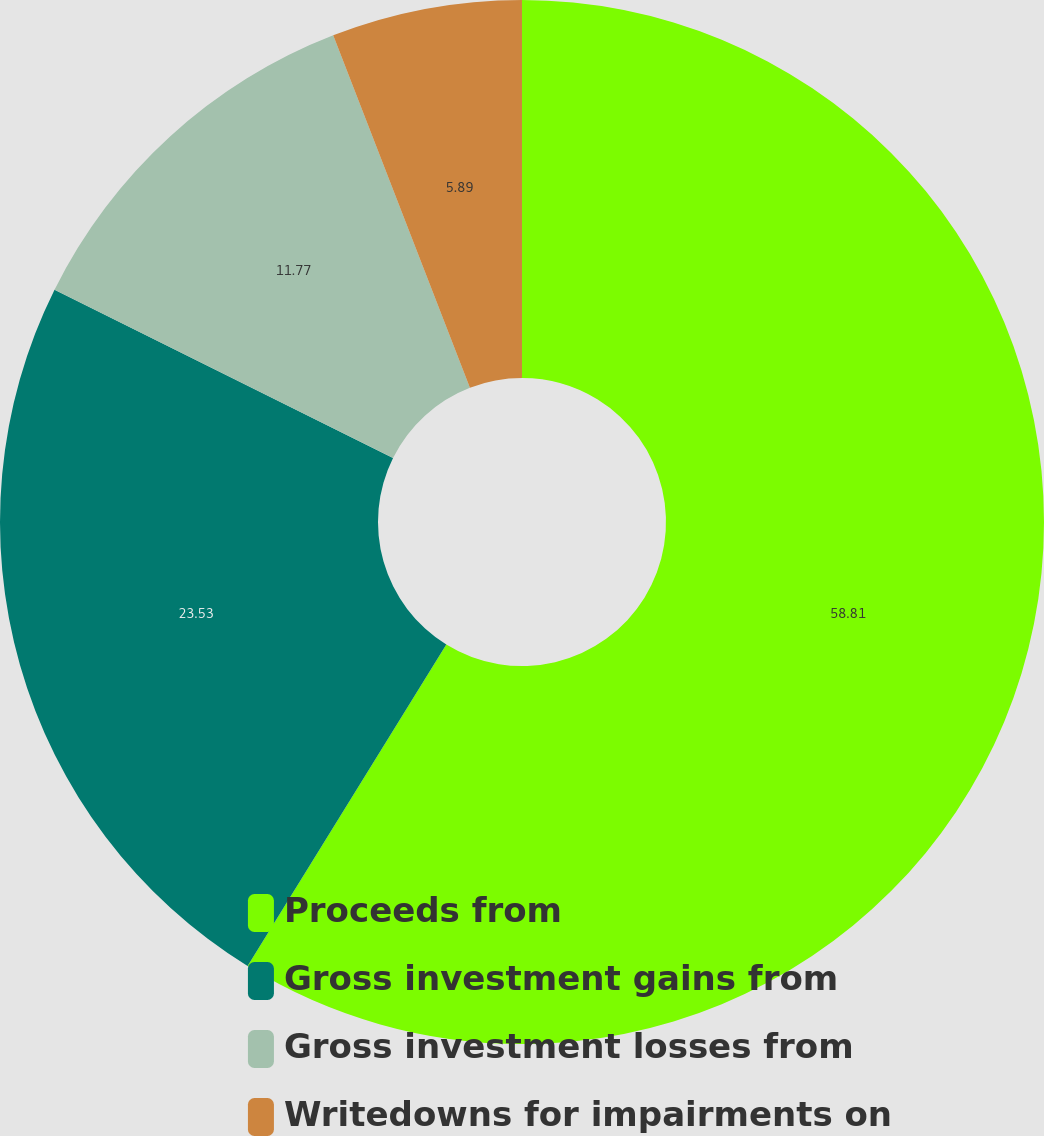Convert chart. <chart><loc_0><loc_0><loc_500><loc_500><pie_chart><fcel>Proceeds from<fcel>Gross investment gains from<fcel>Gross investment losses from<fcel>Writedowns for impairments on<nl><fcel>58.81%<fcel>23.53%<fcel>11.77%<fcel>5.89%<nl></chart> 